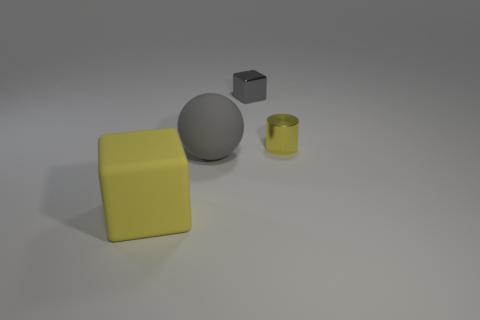Add 2 cyan metal spheres. How many objects exist? 6 Subtract all cylinders. How many objects are left? 3 Subtract all yellow cubes. Subtract all gray things. How many objects are left? 1 Add 1 big yellow matte blocks. How many big yellow matte blocks are left? 2 Add 1 yellow matte cubes. How many yellow matte cubes exist? 2 Subtract 0 purple balls. How many objects are left? 4 